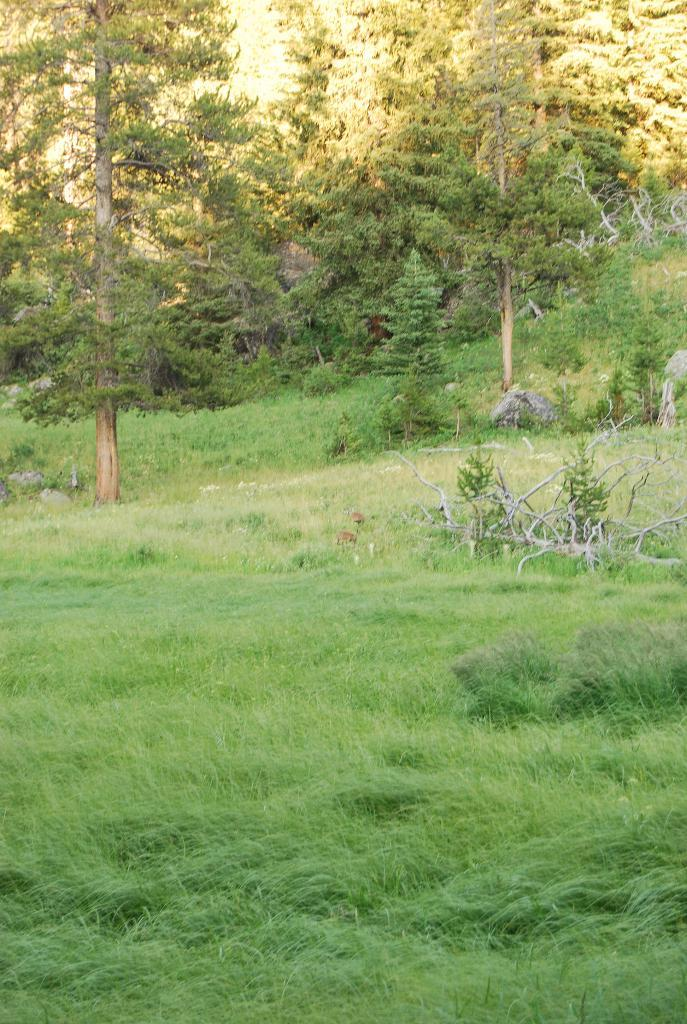What type of vegetation can be seen in the image? There are green trees and green grass in the image. What color are the trees and grass in the image? The trees and grass are green in the image. What type of lumber can be seen in the image? There is no lumber present in the image; it only features green trees and grass. Can you spot a frog among the green trees and grass in the image? There is no frog visible in the image; it only features green trees and grass. 